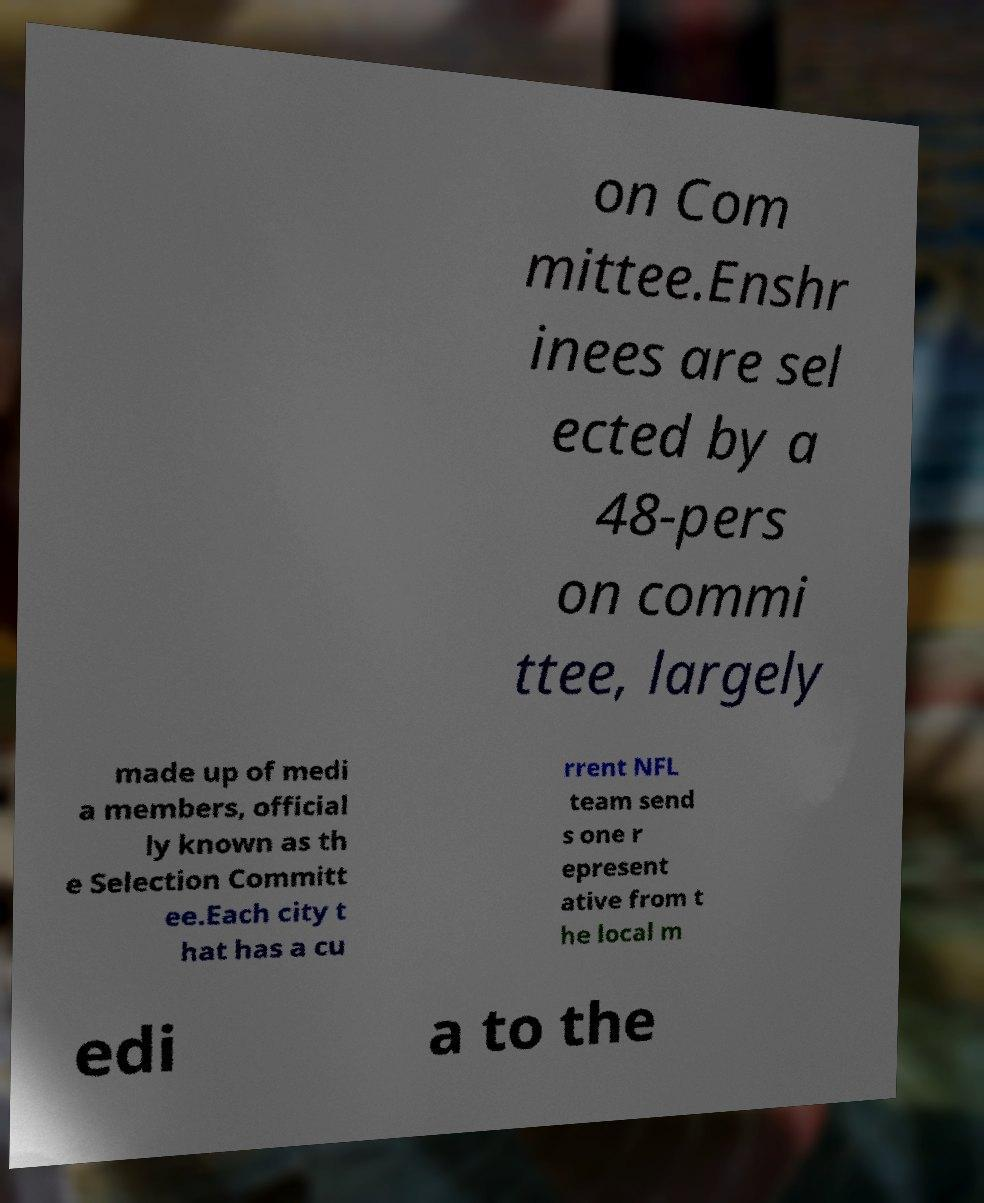For documentation purposes, I need the text within this image transcribed. Could you provide that? on Com mittee.Enshr inees are sel ected by a 48-pers on commi ttee, largely made up of medi a members, official ly known as th e Selection Committ ee.Each city t hat has a cu rrent NFL team send s one r epresent ative from t he local m edi a to the 